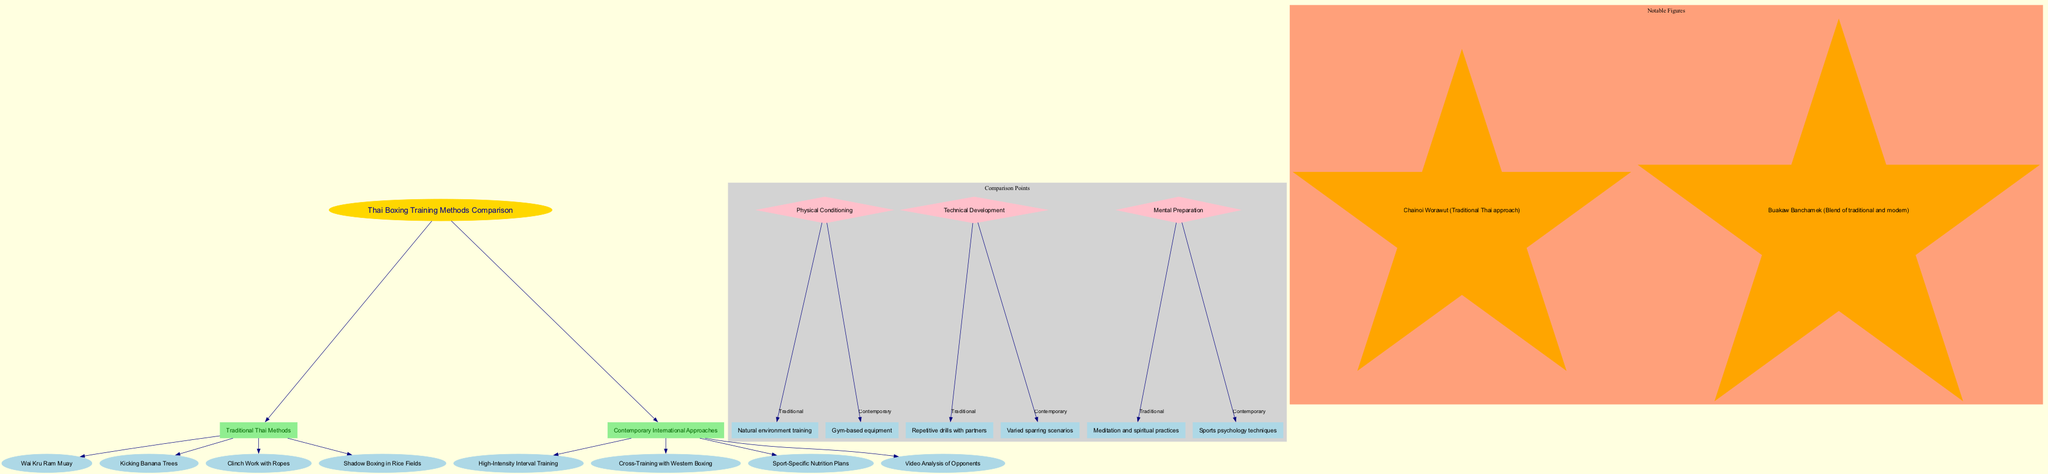What is the central topic of the diagram? The title or central topic is found in the central node of the diagram, labeled "Thai Boxing Training Methods Comparison".
Answer: Thai Boxing Training Methods Comparison How many main branches are there in the diagram? The main branches are the primary divisions connected to the central topic. Analyzing the connections shows there are two main branches: "Traditional Thai Methods" and "Contemporary International Approaches".
Answer: 2 What training method is used in traditional Thai boxing for kicking practice? The sub-branch under the "Traditional Thai Methods" related to kicking practice specifically lists "Kicking Banana Trees".
Answer: Kicking Banana Trees What aspect highlights the difference in technical development between traditional and contemporary training? In the comparison points, the aspect specified is "Technical Development", showing the differing methods between traditional and contemporary practices: repetitive drills with partners versus varied sparring scenarios.
Answer: Technical Development Which notable figure represents the traditional Thai approach? Among the notable figures identified in the last section of the diagram, the figure representing the traditional Thai approach is Chainoi Worawut.
Answer: Chainoi Worawut What physical conditioning method does traditional Thai boxing rely on? In the comparison points, the aspect of "Physical Conditioning" details the traditional approach as "Natural environment training", differentiating it from contemporary methods.
Answer: Natural environment training Which contemporary approach focuses on nutrition? Among the sub-branches for contemporary approaches, the method concerning nutrition is detailed as "Sport-Specific Nutrition Plans". This indicates a specialized focus not highlighted in traditional methods.
Answer: Sport-Specific Nutrition Plans What is a mental preparation technique used in traditional Thai boxing? The comparison point for mental preparation identifies the traditional method as "Meditation and spiritual practices", contrasting with approaches from contemporary training.
Answer: Meditation and spiritual practices What represents the connection between traditional and contemporary training methods in this diagram? The diagram visually connects the traditional and contemporary branches through the comparison points which analyze specific aspects shared between the two approaches. Each point draws a parallel or contrast providing an organized comparison of methodologies.
Answer: Comparison Points 